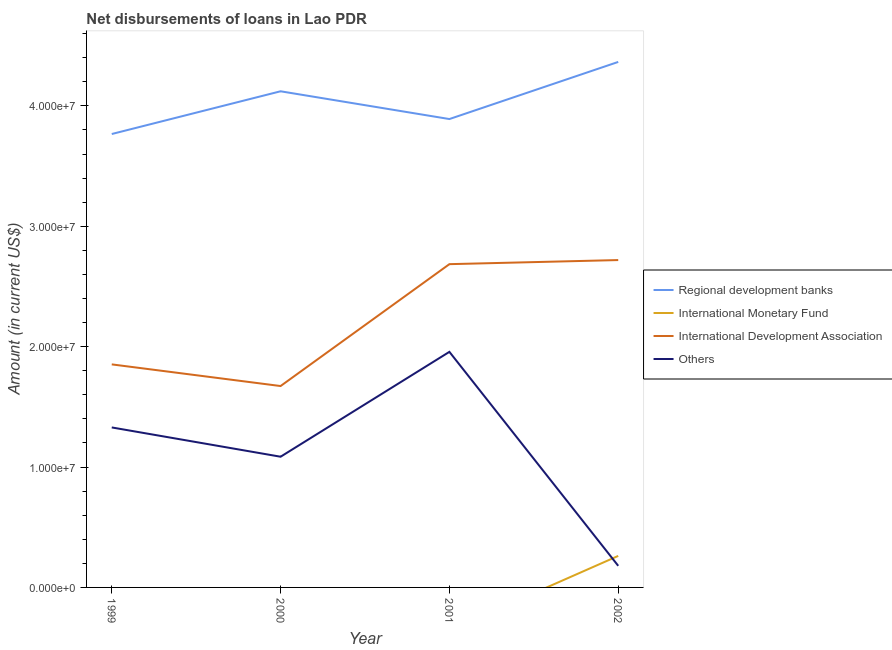What is the amount of loan disimbursed by international development association in 2001?
Give a very brief answer. 2.69e+07. Across all years, what is the maximum amount of loan disimbursed by regional development banks?
Offer a terse response. 4.37e+07. Across all years, what is the minimum amount of loan disimbursed by regional development banks?
Your answer should be compact. 3.77e+07. What is the total amount of loan disimbursed by regional development banks in the graph?
Give a very brief answer. 1.61e+08. What is the difference between the amount of loan disimbursed by international development association in 1999 and that in 2002?
Your answer should be very brief. -8.67e+06. What is the difference between the amount of loan disimbursed by international monetary fund in 2002 and the amount of loan disimbursed by other organisations in 2001?
Ensure brevity in your answer.  -1.70e+07. What is the average amount of loan disimbursed by regional development banks per year?
Your answer should be very brief. 4.04e+07. In the year 2000, what is the difference between the amount of loan disimbursed by international development association and amount of loan disimbursed by regional development banks?
Your answer should be compact. -2.45e+07. What is the ratio of the amount of loan disimbursed by international development association in 2000 to that in 2001?
Make the answer very short. 0.62. What is the difference between the highest and the lowest amount of loan disimbursed by international development association?
Your answer should be very brief. 1.05e+07. In how many years, is the amount of loan disimbursed by international development association greater than the average amount of loan disimbursed by international development association taken over all years?
Offer a terse response. 2. Does the amount of loan disimbursed by international monetary fund monotonically increase over the years?
Provide a succinct answer. Yes. Is the amount of loan disimbursed by regional development banks strictly less than the amount of loan disimbursed by international development association over the years?
Provide a short and direct response. No. How many lines are there?
Give a very brief answer. 4. What is the difference between two consecutive major ticks on the Y-axis?
Give a very brief answer. 1.00e+07. Does the graph contain grids?
Ensure brevity in your answer.  No. Where does the legend appear in the graph?
Your response must be concise. Center right. How many legend labels are there?
Ensure brevity in your answer.  4. What is the title of the graph?
Ensure brevity in your answer.  Net disbursements of loans in Lao PDR. Does "Labor Taxes" appear as one of the legend labels in the graph?
Your response must be concise. No. What is the label or title of the X-axis?
Your answer should be compact. Year. What is the Amount (in current US$) in Regional development banks in 1999?
Give a very brief answer. 3.77e+07. What is the Amount (in current US$) of International Monetary Fund in 1999?
Provide a short and direct response. 0. What is the Amount (in current US$) in International Development Association in 1999?
Offer a very short reply. 1.85e+07. What is the Amount (in current US$) of Others in 1999?
Give a very brief answer. 1.33e+07. What is the Amount (in current US$) in Regional development banks in 2000?
Give a very brief answer. 4.12e+07. What is the Amount (in current US$) in International Development Association in 2000?
Offer a very short reply. 1.67e+07. What is the Amount (in current US$) in Others in 2000?
Provide a succinct answer. 1.09e+07. What is the Amount (in current US$) in Regional development banks in 2001?
Ensure brevity in your answer.  3.89e+07. What is the Amount (in current US$) of International Monetary Fund in 2001?
Make the answer very short. 0. What is the Amount (in current US$) of International Development Association in 2001?
Offer a very short reply. 2.69e+07. What is the Amount (in current US$) in Others in 2001?
Provide a short and direct response. 1.96e+07. What is the Amount (in current US$) in Regional development banks in 2002?
Offer a terse response. 4.37e+07. What is the Amount (in current US$) in International Monetary Fund in 2002?
Ensure brevity in your answer.  2.62e+06. What is the Amount (in current US$) of International Development Association in 2002?
Ensure brevity in your answer.  2.72e+07. What is the Amount (in current US$) in Others in 2002?
Your answer should be compact. 1.80e+06. Across all years, what is the maximum Amount (in current US$) of Regional development banks?
Ensure brevity in your answer.  4.37e+07. Across all years, what is the maximum Amount (in current US$) in International Monetary Fund?
Offer a very short reply. 2.62e+06. Across all years, what is the maximum Amount (in current US$) of International Development Association?
Offer a terse response. 2.72e+07. Across all years, what is the maximum Amount (in current US$) of Others?
Ensure brevity in your answer.  1.96e+07. Across all years, what is the minimum Amount (in current US$) of Regional development banks?
Give a very brief answer. 3.77e+07. Across all years, what is the minimum Amount (in current US$) of International Development Association?
Your response must be concise. 1.67e+07. Across all years, what is the minimum Amount (in current US$) in Others?
Keep it short and to the point. 1.80e+06. What is the total Amount (in current US$) in Regional development banks in the graph?
Keep it short and to the point. 1.61e+08. What is the total Amount (in current US$) in International Monetary Fund in the graph?
Ensure brevity in your answer.  2.62e+06. What is the total Amount (in current US$) in International Development Association in the graph?
Give a very brief answer. 8.93e+07. What is the total Amount (in current US$) of Others in the graph?
Keep it short and to the point. 4.55e+07. What is the difference between the Amount (in current US$) of Regional development banks in 1999 and that in 2000?
Your answer should be compact. -3.55e+06. What is the difference between the Amount (in current US$) of International Development Association in 1999 and that in 2000?
Keep it short and to the point. 1.80e+06. What is the difference between the Amount (in current US$) in Others in 1999 and that in 2000?
Keep it short and to the point. 2.43e+06. What is the difference between the Amount (in current US$) of Regional development banks in 1999 and that in 2001?
Provide a succinct answer. -1.24e+06. What is the difference between the Amount (in current US$) of International Development Association in 1999 and that in 2001?
Offer a terse response. -8.33e+06. What is the difference between the Amount (in current US$) in Others in 1999 and that in 2001?
Provide a short and direct response. -6.28e+06. What is the difference between the Amount (in current US$) of Regional development banks in 1999 and that in 2002?
Keep it short and to the point. -5.99e+06. What is the difference between the Amount (in current US$) of International Development Association in 1999 and that in 2002?
Your response must be concise. -8.67e+06. What is the difference between the Amount (in current US$) of Others in 1999 and that in 2002?
Ensure brevity in your answer.  1.15e+07. What is the difference between the Amount (in current US$) of Regional development banks in 2000 and that in 2001?
Provide a succinct answer. 2.31e+06. What is the difference between the Amount (in current US$) in International Development Association in 2000 and that in 2001?
Provide a short and direct response. -1.01e+07. What is the difference between the Amount (in current US$) in Others in 2000 and that in 2001?
Give a very brief answer. -8.71e+06. What is the difference between the Amount (in current US$) in Regional development banks in 2000 and that in 2002?
Offer a terse response. -2.44e+06. What is the difference between the Amount (in current US$) in International Development Association in 2000 and that in 2002?
Your answer should be very brief. -1.05e+07. What is the difference between the Amount (in current US$) of Others in 2000 and that in 2002?
Your answer should be compact. 9.06e+06. What is the difference between the Amount (in current US$) in Regional development banks in 2001 and that in 2002?
Ensure brevity in your answer.  -4.74e+06. What is the difference between the Amount (in current US$) of International Development Association in 2001 and that in 2002?
Provide a short and direct response. -3.40e+05. What is the difference between the Amount (in current US$) in Others in 2001 and that in 2002?
Ensure brevity in your answer.  1.78e+07. What is the difference between the Amount (in current US$) of Regional development banks in 1999 and the Amount (in current US$) of International Development Association in 2000?
Offer a terse response. 2.09e+07. What is the difference between the Amount (in current US$) of Regional development banks in 1999 and the Amount (in current US$) of Others in 2000?
Ensure brevity in your answer.  2.68e+07. What is the difference between the Amount (in current US$) in International Development Association in 1999 and the Amount (in current US$) in Others in 2000?
Offer a terse response. 7.67e+06. What is the difference between the Amount (in current US$) of Regional development banks in 1999 and the Amount (in current US$) of International Development Association in 2001?
Your answer should be very brief. 1.08e+07. What is the difference between the Amount (in current US$) of Regional development banks in 1999 and the Amount (in current US$) of Others in 2001?
Make the answer very short. 1.81e+07. What is the difference between the Amount (in current US$) of International Development Association in 1999 and the Amount (in current US$) of Others in 2001?
Give a very brief answer. -1.04e+06. What is the difference between the Amount (in current US$) in Regional development banks in 1999 and the Amount (in current US$) in International Monetary Fund in 2002?
Offer a terse response. 3.50e+07. What is the difference between the Amount (in current US$) in Regional development banks in 1999 and the Amount (in current US$) in International Development Association in 2002?
Offer a very short reply. 1.05e+07. What is the difference between the Amount (in current US$) in Regional development banks in 1999 and the Amount (in current US$) in Others in 2002?
Make the answer very short. 3.59e+07. What is the difference between the Amount (in current US$) in International Development Association in 1999 and the Amount (in current US$) in Others in 2002?
Provide a succinct answer. 1.67e+07. What is the difference between the Amount (in current US$) in Regional development banks in 2000 and the Amount (in current US$) in International Development Association in 2001?
Ensure brevity in your answer.  1.44e+07. What is the difference between the Amount (in current US$) in Regional development banks in 2000 and the Amount (in current US$) in Others in 2001?
Give a very brief answer. 2.16e+07. What is the difference between the Amount (in current US$) in International Development Association in 2000 and the Amount (in current US$) in Others in 2001?
Provide a succinct answer. -2.84e+06. What is the difference between the Amount (in current US$) in Regional development banks in 2000 and the Amount (in current US$) in International Monetary Fund in 2002?
Provide a succinct answer. 3.86e+07. What is the difference between the Amount (in current US$) in Regional development banks in 2000 and the Amount (in current US$) in International Development Association in 2002?
Provide a succinct answer. 1.40e+07. What is the difference between the Amount (in current US$) of Regional development banks in 2000 and the Amount (in current US$) of Others in 2002?
Your answer should be very brief. 3.94e+07. What is the difference between the Amount (in current US$) of International Development Association in 2000 and the Amount (in current US$) of Others in 2002?
Offer a very short reply. 1.49e+07. What is the difference between the Amount (in current US$) in Regional development banks in 2001 and the Amount (in current US$) in International Monetary Fund in 2002?
Your response must be concise. 3.63e+07. What is the difference between the Amount (in current US$) in Regional development banks in 2001 and the Amount (in current US$) in International Development Association in 2002?
Keep it short and to the point. 1.17e+07. What is the difference between the Amount (in current US$) in Regional development banks in 2001 and the Amount (in current US$) in Others in 2002?
Ensure brevity in your answer.  3.71e+07. What is the difference between the Amount (in current US$) in International Development Association in 2001 and the Amount (in current US$) in Others in 2002?
Offer a very short reply. 2.51e+07. What is the average Amount (in current US$) of Regional development banks per year?
Your response must be concise. 4.04e+07. What is the average Amount (in current US$) of International Monetary Fund per year?
Ensure brevity in your answer.  6.54e+05. What is the average Amount (in current US$) in International Development Association per year?
Offer a terse response. 2.23e+07. What is the average Amount (in current US$) in Others per year?
Ensure brevity in your answer.  1.14e+07. In the year 1999, what is the difference between the Amount (in current US$) of Regional development banks and Amount (in current US$) of International Development Association?
Offer a very short reply. 1.91e+07. In the year 1999, what is the difference between the Amount (in current US$) of Regional development banks and Amount (in current US$) of Others?
Offer a very short reply. 2.44e+07. In the year 1999, what is the difference between the Amount (in current US$) of International Development Association and Amount (in current US$) of Others?
Give a very brief answer. 5.24e+06. In the year 2000, what is the difference between the Amount (in current US$) in Regional development banks and Amount (in current US$) in International Development Association?
Offer a very short reply. 2.45e+07. In the year 2000, what is the difference between the Amount (in current US$) in Regional development banks and Amount (in current US$) in Others?
Give a very brief answer. 3.04e+07. In the year 2000, what is the difference between the Amount (in current US$) in International Development Association and Amount (in current US$) in Others?
Provide a succinct answer. 5.87e+06. In the year 2001, what is the difference between the Amount (in current US$) in Regional development banks and Amount (in current US$) in International Development Association?
Your answer should be compact. 1.21e+07. In the year 2001, what is the difference between the Amount (in current US$) of Regional development banks and Amount (in current US$) of Others?
Provide a short and direct response. 1.93e+07. In the year 2001, what is the difference between the Amount (in current US$) of International Development Association and Amount (in current US$) of Others?
Give a very brief answer. 7.28e+06. In the year 2002, what is the difference between the Amount (in current US$) of Regional development banks and Amount (in current US$) of International Monetary Fund?
Your answer should be compact. 4.10e+07. In the year 2002, what is the difference between the Amount (in current US$) of Regional development banks and Amount (in current US$) of International Development Association?
Offer a terse response. 1.65e+07. In the year 2002, what is the difference between the Amount (in current US$) in Regional development banks and Amount (in current US$) in Others?
Give a very brief answer. 4.19e+07. In the year 2002, what is the difference between the Amount (in current US$) of International Monetary Fund and Amount (in current US$) of International Development Association?
Your response must be concise. -2.46e+07. In the year 2002, what is the difference between the Amount (in current US$) in International Monetary Fund and Amount (in current US$) in Others?
Keep it short and to the point. 8.23e+05. In the year 2002, what is the difference between the Amount (in current US$) in International Development Association and Amount (in current US$) in Others?
Give a very brief answer. 2.54e+07. What is the ratio of the Amount (in current US$) in Regional development banks in 1999 to that in 2000?
Ensure brevity in your answer.  0.91. What is the ratio of the Amount (in current US$) of International Development Association in 1999 to that in 2000?
Offer a very short reply. 1.11. What is the ratio of the Amount (in current US$) of Others in 1999 to that in 2000?
Your response must be concise. 1.22. What is the ratio of the Amount (in current US$) in Regional development banks in 1999 to that in 2001?
Provide a short and direct response. 0.97. What is the ratio of the Amount (in current US$) in International Development Association in 1999 to that in 2001?
Your response must be concise. 0.69. What is the ratio of the Amount (in current US$) in Others in 1999 to that in 2001?
Offer a very short reply. 0.68. What is the ratio of the Amount (in current US$) in Regional development banks in 1999 to that in 2002?
Give a very brief answer. 0.86. What is the ratio of the Amount (in current US$) in International Development Association in 1999 to that in 2002?
Your answer should be very brief. 0.68. What is the ratio of the Amount (in current US$) of Others in 1999 to that in 2002?
Your response must be concise. 7.4. What is the ratio of the Amount (in current US$) of Regional development banks in 2000 to that in 2001?
Give a very brief answer. 1.06. What is the ratio of the Amount (in current US$) in International Development Association in 2000 to that in 2001?
Your answer should be compact. 0.62. What is the ratio of the Amount (in current US$) of Others in 2000 to that in 2001?
Make the answer very short. 0.55. What is the ratio of the Amount (in current US$) in Regional development banks in 2000 to that in 2002?
Your response must be concise. 0.94. What is the ratio of the Amount (in current US$) of International Development Association in 2000 to that in 2002?
Offer a terse response. 0.62. What is the ratio of the Amount (in current US$) of Others in 2000 to that in 2002?
Offer a very short reply. 6.05. What is the ratio of the Amount (in current US$) of Regional development banks in 2001 to that in 2002?
Keep it short and to the point. 0.89. What is the ratio of the Amount (in current US$) of International Development Association in 2001 to that in 2002?
Ensure brevity in your answer.  0.99. What is the ratio of the Amount (in current US$) in Others in 2001 to that in 2002?
Offer a terse response. 10.9. What is the difference between the highest and the second highest Amount (in current US$) in Regional development banks?
Your response must be concise. 2.44e+06. What is the difference between the highest and the second highest Amount (in current US$) of International Development Association?
Provide a succinct answer. 3.40e+05. What is the difference between the highest and the second highest Amount (in current US$) in Others?
Your answer should be compact. 6.28e+06. What is the difference between the highest and the lowest Amount (in current US$) in Regional development banks?
Make the answer very short. 5.99e+06. What is the difference between the highest and the lowest Amount (in current US$) of International Monetary Fund?
Provide a short and direct response. 2.62e+06. What is the difference between the highest and the lowest Amount (in current US$) of International Development Association?
Your answer should be very brief. 1.05e+07. What is the difference between the highest and the lowest Amount (in current US$) of Others?
Provide a short and direct response. 1.78e+07. 